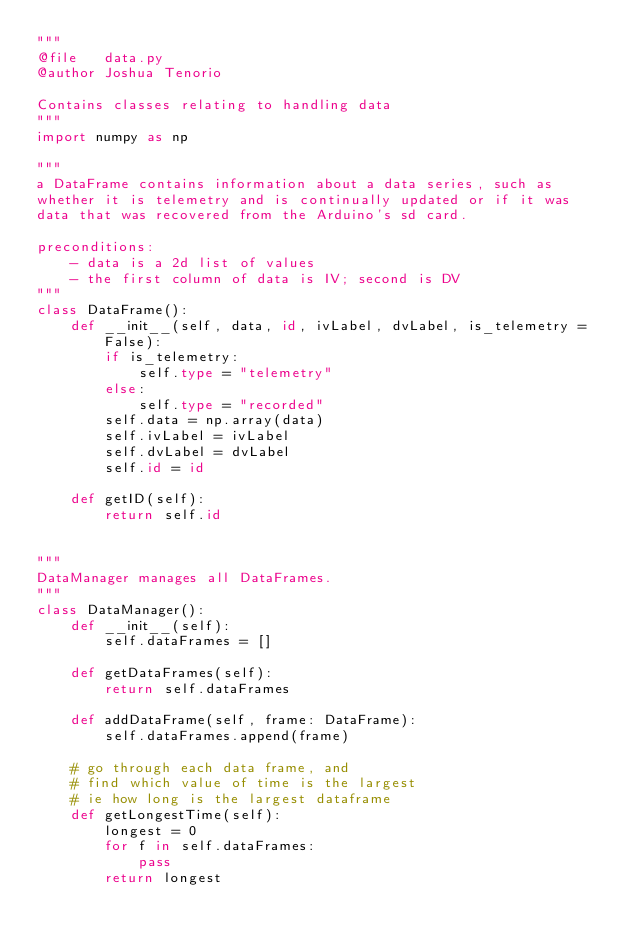<code> <loc_0><loc_0><loc_500><loc_500><_Python_>"""
@file   data.py
@author Joshua Tenorio

Contains classes relating to handling data
"""
import numpy as np

"""
a DataFrame contains information about a data series, such as 
whether it is telemetry and is continually updated or if it was
data that was recovered from the Arduino's sd card.

preconditions:
    - data is a 2d list of values
    - the first column of data is IV; second is DV
"""
class DataFrame():
    def __init__(self, data, id, ivLabel, dvLabel, is_telemetry = False):
        if is_telemetry:
            self.type = "telemetry"
        else:
            self.type = "recorded"
        self.data = np.array(data)
        self.ivLabel = ivLabel
        self.dvLabel = dvLabel
        self.id = id
    
    def getID(self):
        return self.id


"""
DataManager manages all DataFrames.
"""
class DataManager():
    def __init__(self):
        self.dataFrames = []

    def getDataFrames(self):
        return self.dataFrames
    
    def addDataFrame(self, frame: DataFrame):
        self.dataFrames.append(frame)

    # go through each data frame, and
    # find which value of time is the largest
    # ie how long is the largest dataframe
    def getLongestTime(self):
        longest = 0
        for f in self.dataFrames:
            pass
        return longest
</code> 